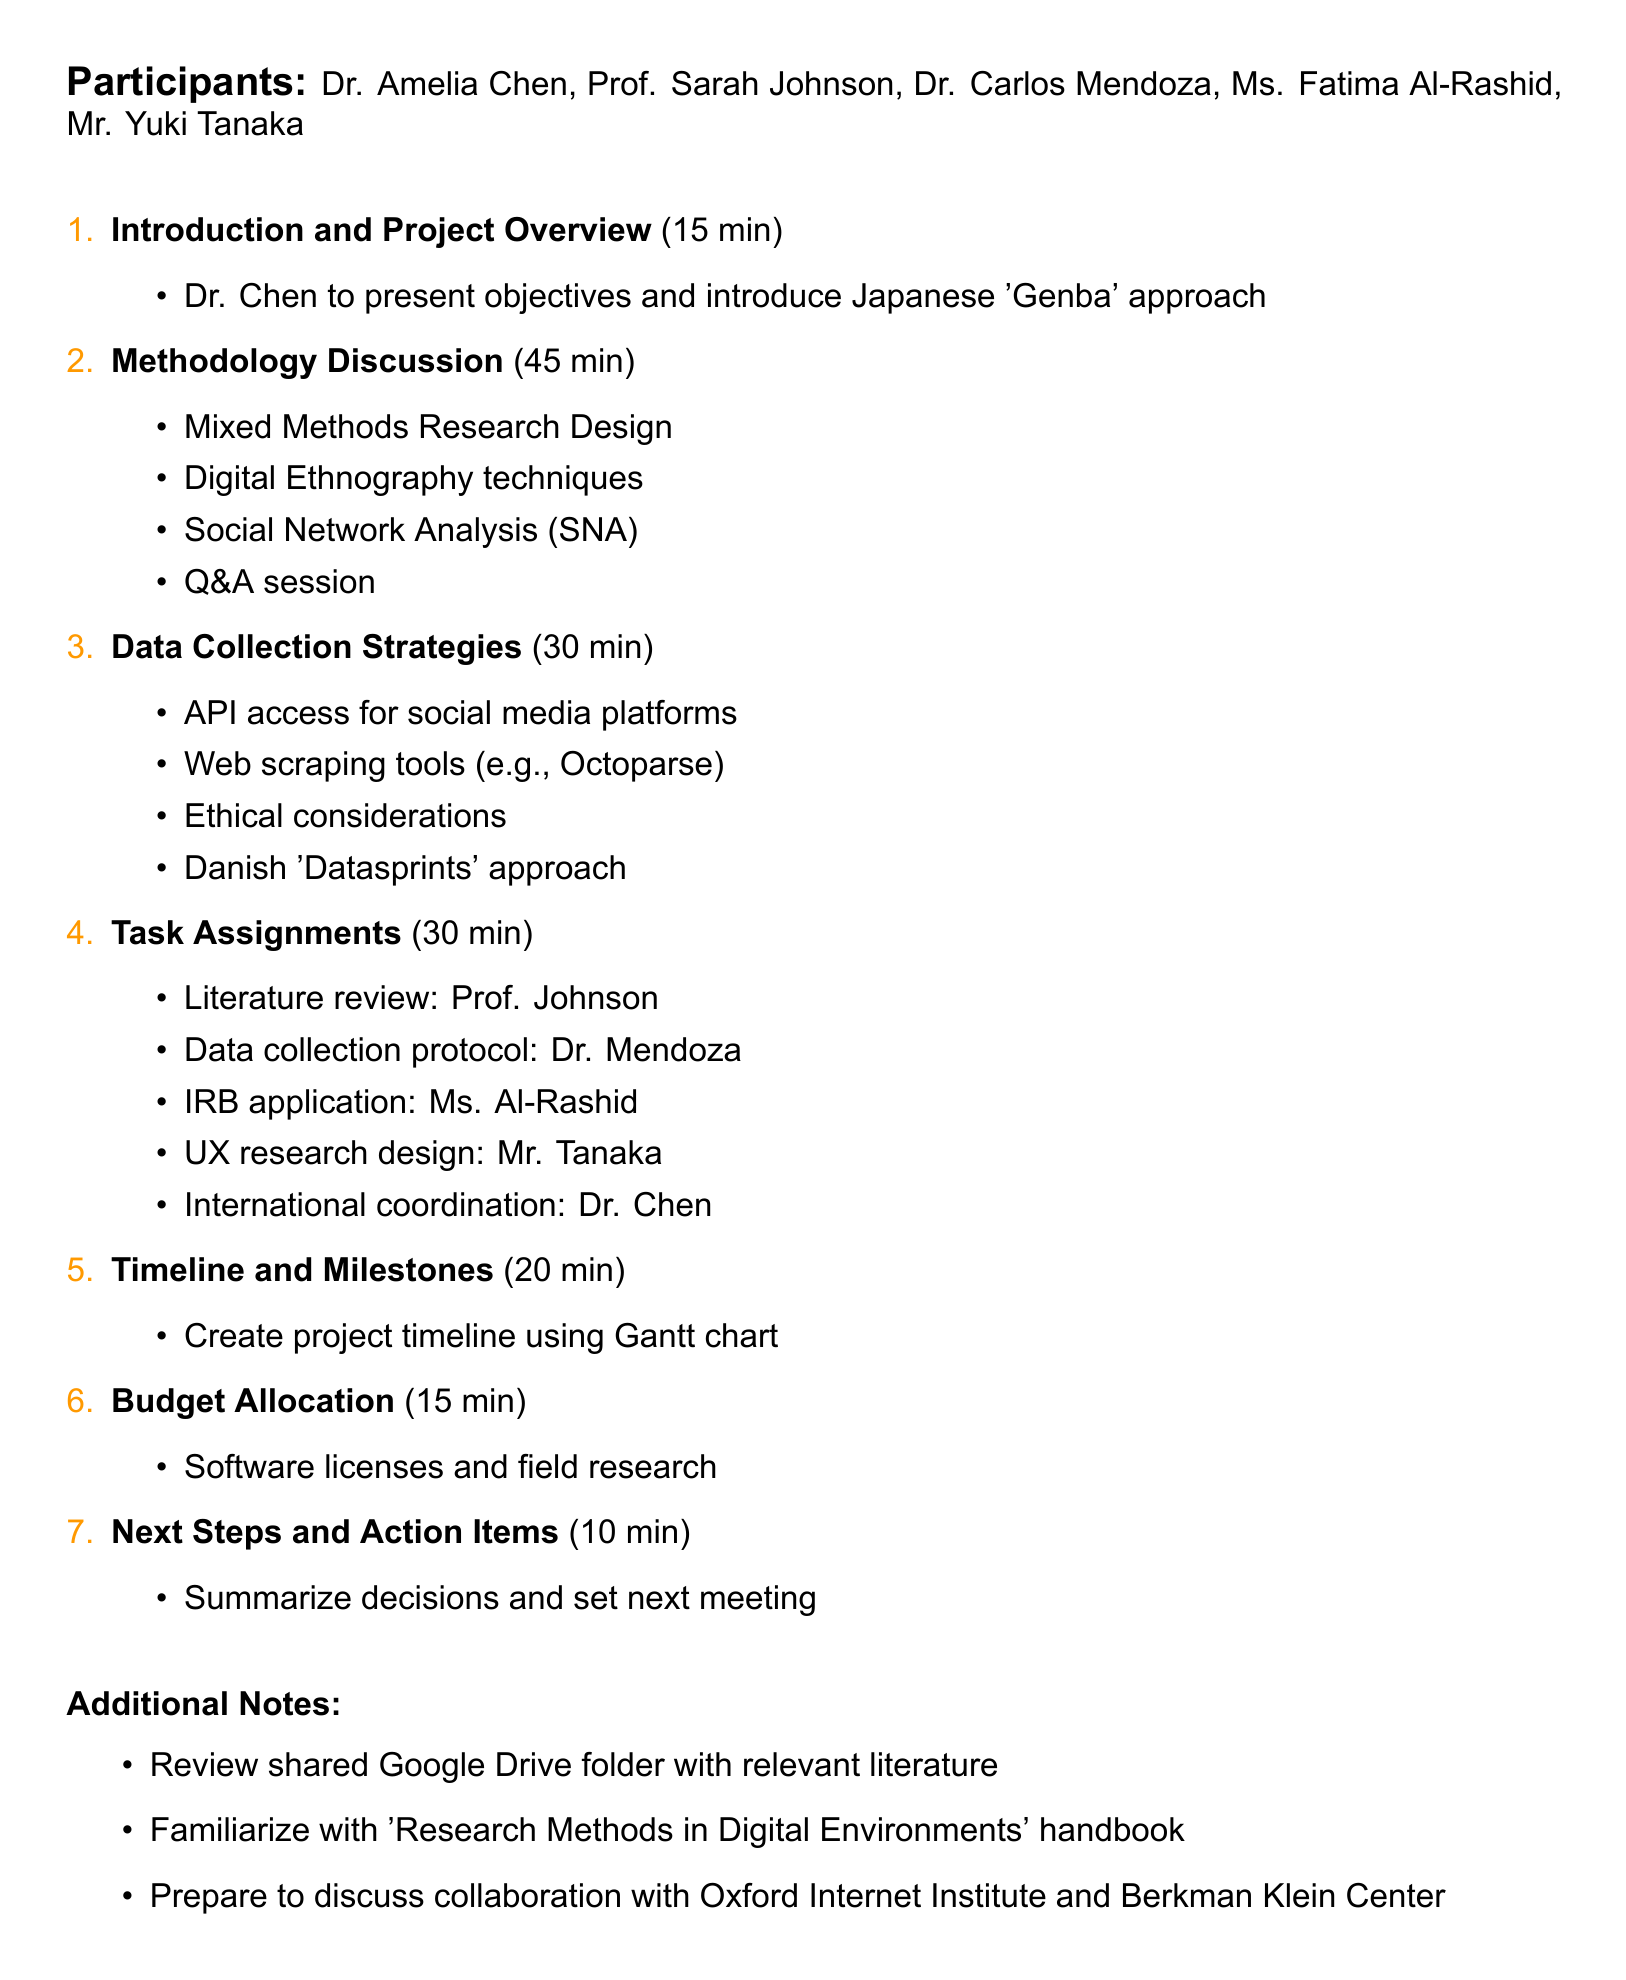What is the meeting title? The meeting title is directly stated at the start of the document, identifying the subject of the meeting.
Answer: Global Digital Media Trends Research Project Planning Who is the lead researcher? The lead researcher is indicated among the listed participants, highlighting the person in charge of the project.
Answer: Dr. Amelia Chen How long is the methodology discussion scheduled for? The duration of the methodology discussion is specified in the agenda, providing clarity on the time allocation for this item.
Answer: 45 minutes What methodology will Dr. Chen introduce? The document details the specific methodological concept that Dr. Chen will present during the introduction segment of the meeting.
Answer: Japanese 'Genba' approach Which software is mentioned for budget allocation? The document includes a list of software relevant to the budget discussion, indicating potential costs for project resources.
Answer: NVivo, MAXQDA What is the total duration of the meeting? The meeting's total duration can be calculated by summing the individual durations listed in the agenda items.
Answer: 2 hours 30 minutes Who is responsible for the literature review? The task assignments section specifies which participant is tasked with the literature review, revealing individual responsibilities.
Answer: Prof. Johnson What is one ethical consideration mentioned? The document touches upon ethical aspects related to data collection strategies, indicating that these considerations are part of project planning.
Answer: Ethical considerations in digital data collection 